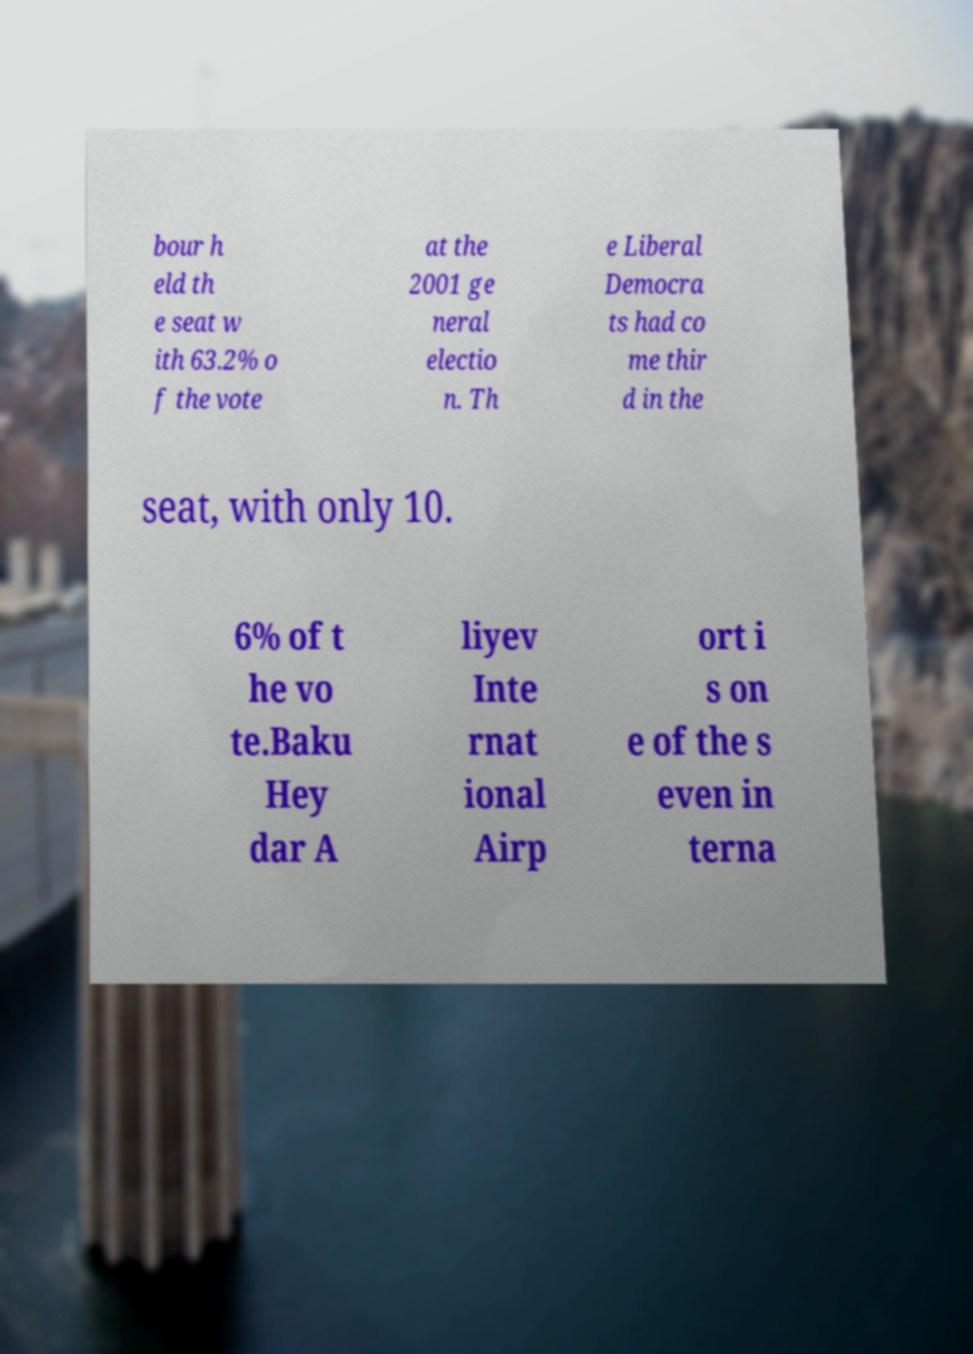What messages or text are displayed in this image? I need them in a readable, typed format. bour h eld th e seat w ith 63.2% o f the vote at the 2001 ge neral electio n. Th e Liberal Democra ts had co me thir d in the seat, with only 10. 6% of t he vo te.Baku Hey dar A liyev Inte rnat ional Airp ort i s on e of the s even in terna 